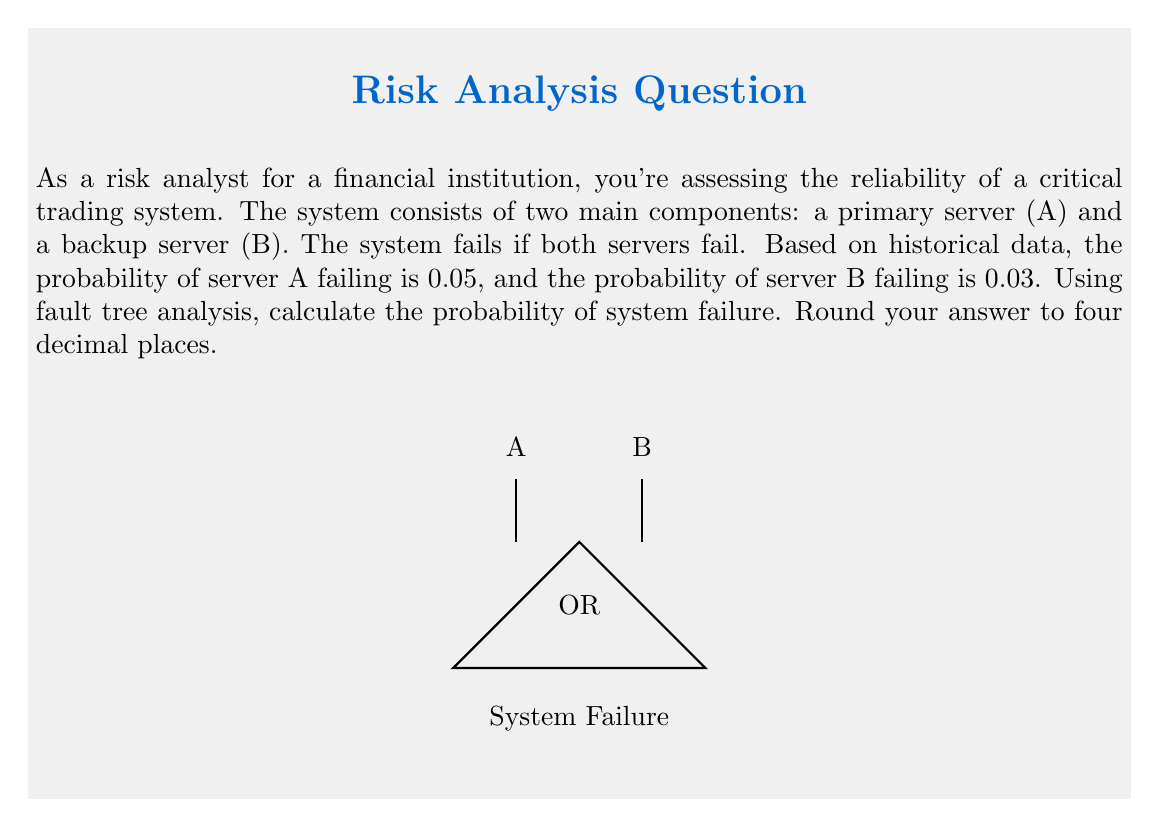Help me with this question. Let's approach this step-by-step:

1) In fault tree analysis, an OR gate is used when the output event occurs if any of the input events occur. In this case, the system fails if both A AND B fail.

2) We need to calculate $P(A \text{ and } B)$, which is the probability of both events occurring.

3) Assuming A and B are independent events (a reasonable assumption for separate servers), we can use the multiplication rule of probability:

   $P(A \text{ and } B) = P(A) \times P(B)$

4) We're given:
   $P(A) = 0.05$ (probability of server A failing)
   $P(B) = 0.03$ (probability of server B failing)

5) Substituting these values:

   $P(\text{System Failure}) = P(A) \times P(B) = 0.05 \times 0.03 = 0.0015$

6) Rounding to four decimal places:

   $P(\text{System Failure}) = 0.0015$

This low probability indicates a relatively reliable system, which aligns with the risk analyst's preference for a "quiet and relaxing business trip".
Answer: 0.0015 